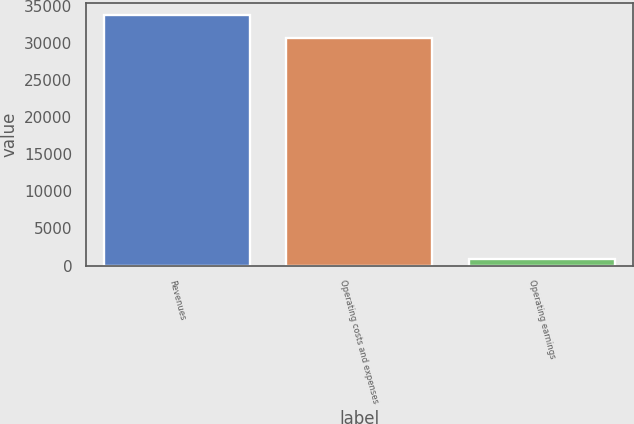Convert chart. <chart><loc_0><loc_0><loc_500><loc_500><bar_chart><fcel>Revenues<fcel>Operating costs and expenses<fcel>Operating earnings<nl><fcel>33748<fcel>30680<fcel>833<nl></chart> 